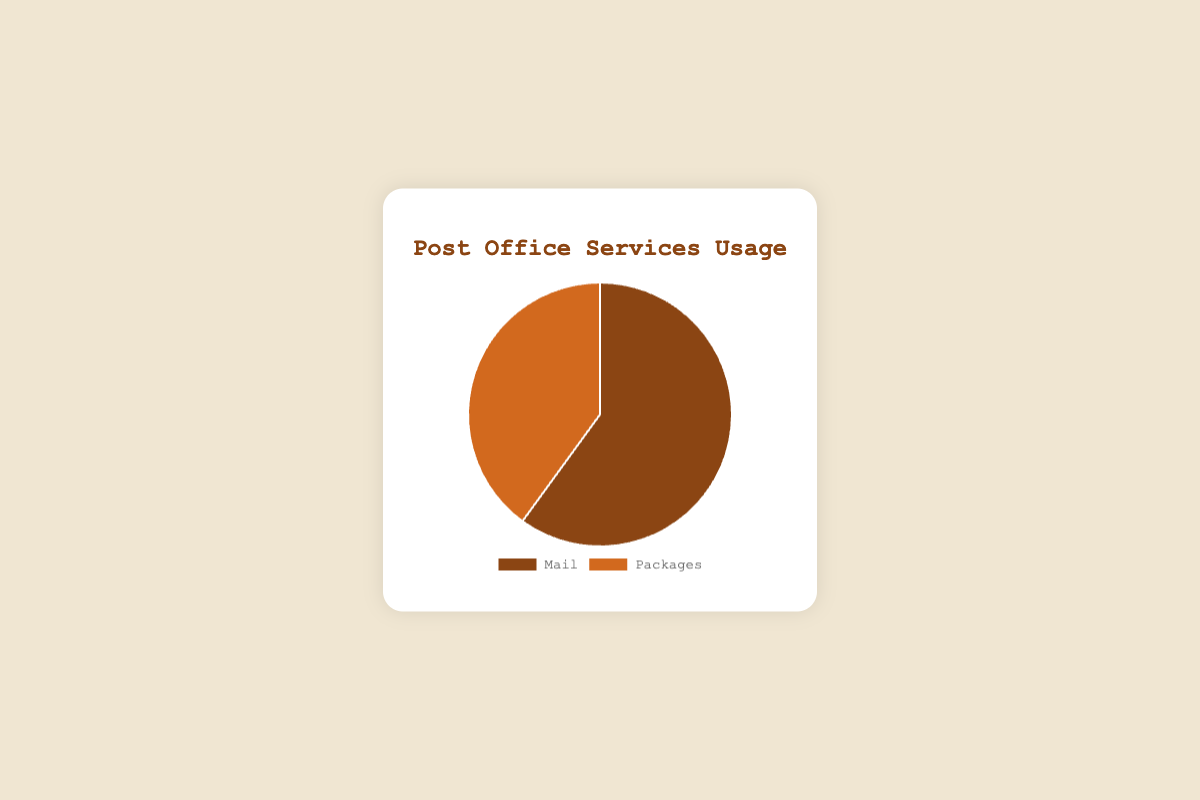What's the most used post office service? The pie chart shows two services: Mail and Packages. Mail has a higher percentage than Packages.
Answer: Mail Which service accounts for 40% of the usage? From the pie chart, Packages account for 40% of the post office services usage.
Answer: Packages How much more is the usage of Mail compared to Packages? The usage of Mail is 60%, and Packages is 40%. The difference is 60% - 40% = 20%.
Answer: 20% What percentage of the services is not Mail? Mail is 60%, so the remaining percentage for Packages is 100% - 60% = 40%.
Answer: 40% If the total usage is 100 services, how many services are for Mail? Mail accounts for 60% of the total usage. 60% of 100 services is 0.6 * 100 = 60 services.
Answer: 60 How many services are for Packages if the total is 200 services? Packages account for 40% of the total usage. 40% of 200 services is 0.4 * 200 = 80 services.
Answer: 80 What fraction of the post office services is used for Packages? The usage of Packages is 40%, which can be expressed as a fraction: 40/100 = 2/5. Therefore, the fraction is 2/5.
Answer: 2/5 What is the ratio of Mail usage to Package usage? The usage of Mail is 60%, and Packages is 40%. The ratio of Mail to Packages is 60:40, which simplifies to 3:2.
Answer: 3:2 